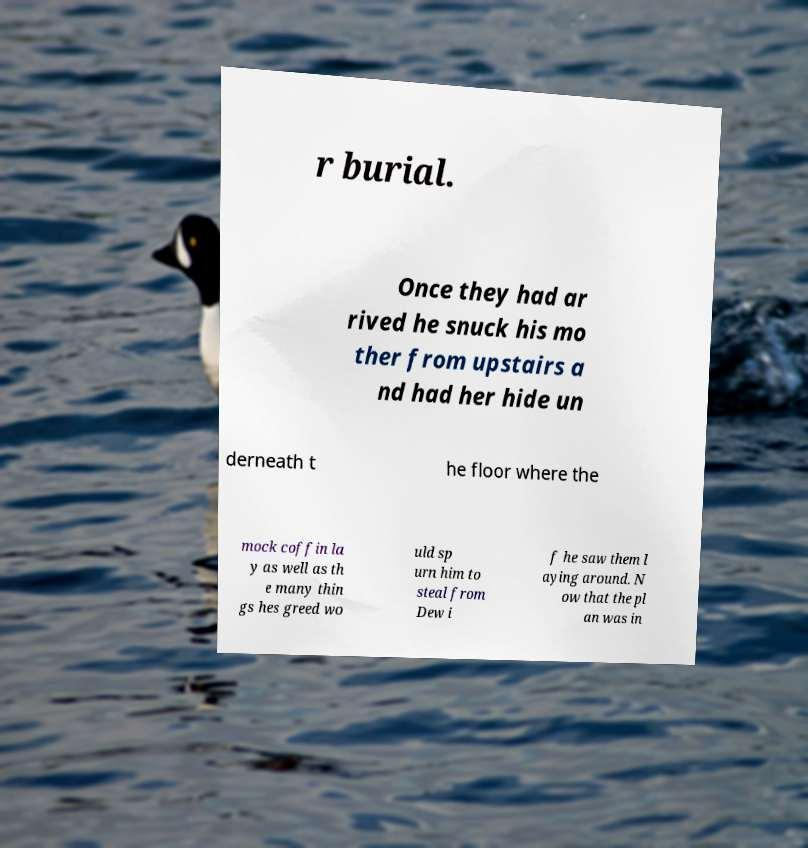Can you read and provide the text displayed in the image?This photo seems to have some interesting text. Can you extract and type it out for me? r burial. Once they had ar rived he snuck his mo ther from upstairs a nd had her hide un derneath t he floor where the mock coffin la y as well as th e many thin gs hes greed wo uld sp urn him to steal from Dew i f he saw them l aying around. N ow that the pl an was in 